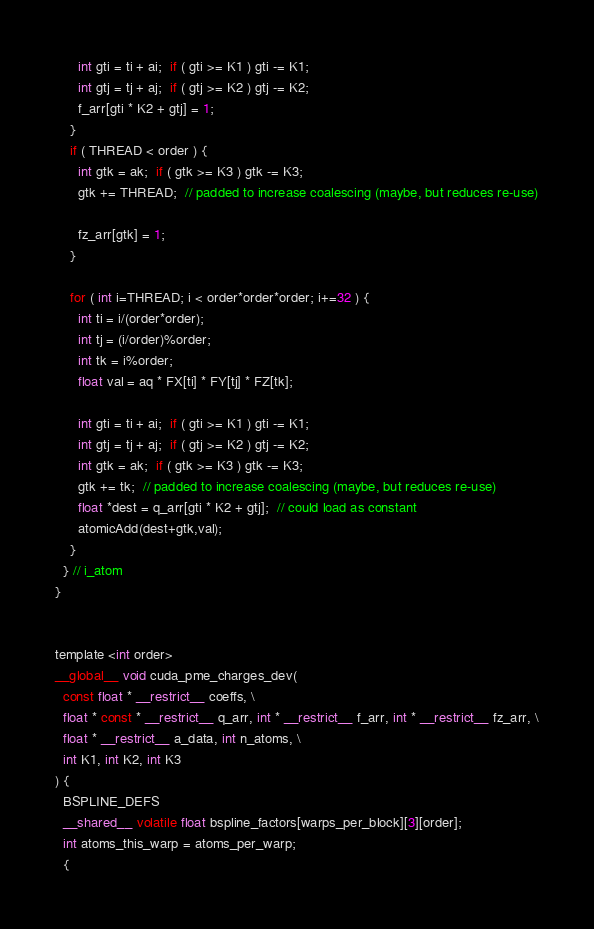Convert code to text. <code><loc_0><loc_0><loc_500><loc_500><_Cuda_>      int gti = ti + ai;  if ( gti >= K1 ) gti -= K1;
      int gtj = tj + aj;  if ( gtj >= K2 ) gtj -= K2;
      f_arr[gti * K2 + gtj] = 1;
    }
    if ( THREAD < order ) {
      int gtk = ak;  if ( gtk >= K3 ) gtk -= K3;
      gtk += THREAD;  // padded to increase coalescing (maybe, but reduces re-use)

      fz_arr[gtk] = 1;
    }

    for ( int i=THREAD; i < order*order*order; i+=32 ) {
      int ti = i/(order*order);
      int tj = (i/order)%order;
      int tk = i%order;
      float val = aq * FX[ti] * FY[tj] * FZ[tk];
      
      int gti = ti + ai;  if ( gti >= K1 ) gti -= K1;
      int gtj = tj + aj;  if ( gtj >= K2 ) gtj -= K2;
      int gtk = ak;  if ( gtk >= K3 ) gtk -= K3;
      gtk += tk;  // padded to increase coalescing (maybe, but reduces re-use)
      float *dest = q_arr[gti * K2 + gtj];  // could load as constant
      atomicAdd(dest+gtk,val);
    }
  } // i_atom
}


template <int order>
__global__ void cuda_pme_charges_dev(
  const float * __restrict__ coeffs, \
  float * const * __restrict__ q_arr, int * __restrict__ f_arr, int * __restrict__ fz_arr, \
  float * __restrict__ a_data, int n_atoms, \
  int K1, int K2, int K3
) {
  BSPLINE_DEFS
  __shared__ volatile float bspline_factors[warps_per_block][3][order];
  int atoms_this_warp = atoms_per_warp;
  {</code> 